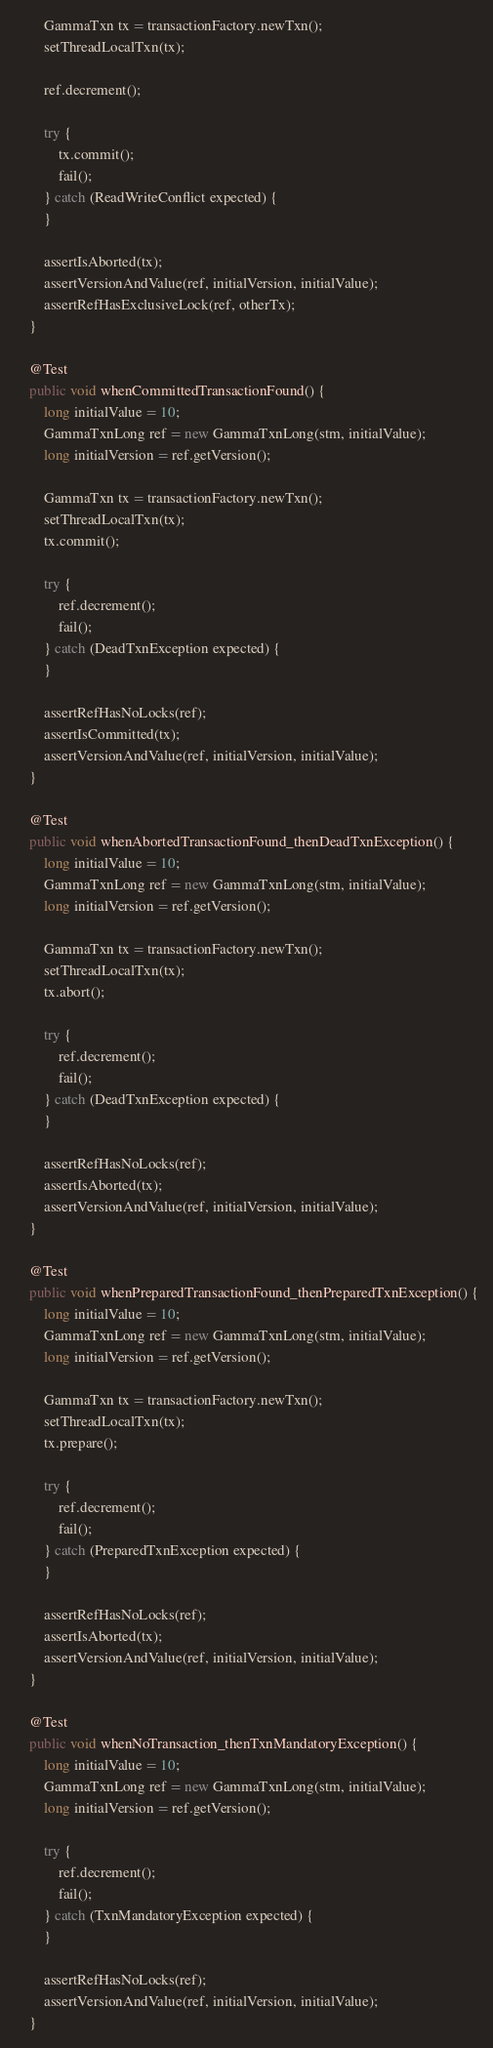<code> <loc_0><loc_0><loc_500><loc_500><_Java_>        GammaTxn tx = transactionFactory.newTxn();
        setThreadLocalTxn(tx);

        ref.decrement();

        try {
            tx.commit();
            fail();
        } catch (ReadWriteConflict expected) {
        }

        assertIsAborted(tx);
        assertVersionAndValue(ref, initialVersion, initialValue);
        assertRefHasExclusiveLock(ref, otherTx);
    }

    @Test
    public void whenCommittedTransactionFound() {
        long initialValue = 10;
        GammaTxnLong ref = new GammaTxnLong(stm, initialValue);
        long initialVersion = ref.getVersion();

        GammaTxn tx = transactionFactory.newTxn();
        setThreadLocalTxn(tx);
        tx.commit();

        try {
            ref.decrement();
            fail();
        } catch (DeadTxnException expected) {
        }

        assertRefHasNoLocks(ref);
        assertIsCommitted(tx);
        assertVersionAndValue(ref, initialVersion, initialValue);
    }

    @Test
    public void whenAbortedTransactionFound_thenDeadTxnException() {
        long initialValue = 10;
        GammaTxnLong ref = new GammaTxnLong(stm, initialValue);
        long initialVersion = ref.getVersion();

        GammaTxn tx = transactionFactory.newTxn();
        setThreadLocalTxn(tx);
        tx.abort();

        try {
            ref.decrement();
            fail();
        } catch (DeadTxnException expected) {
        }

        assertRefHasNoLocks(ref);
        assertIsAborted(tx);
        assertVersionAndValue(ref, initialVersion, initialValue);
    }

    @Test
    public void whenPreparedTransactionFound_thenPreparedTxnException() {
        long initialValue = 10;
        GammaTxnLong ref = new GammaTxnLong(stm, initialValue);
        long initialVersion = ref.getVersion();

        GammaTxn tx = transactionFactory.newTxn();
        setThreadLocalTxn(tx);
        tx.prepare();

        try {
            ref.decrement();
            fail();
        } catch (PreparedTxnException expected) {
        }

        assertRefHasNoLocks(ref);
        assertIsAborted(tx);
        assertVersionAndValue(ref, initialVersion, initialValue);
    }

    @Test
    public void whenNoTransaction_thenTxnMandatoryException() {
        long initialValue = 10;
        GammaTxnLong ref = new GammaTxnLong(stm, initialValue);
        long initialVersion = ref.getVersion();

        try {
            ref.decrement();
            fail();
        } catch (TxnMandatoryException expected) {
        }

        assertRefHasNoLocks(ref);
        assertVersionAndValue(ref, initialVersion, initialValue);
    }
</code> 